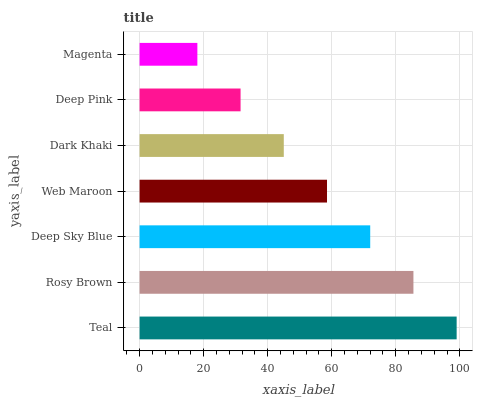Is Magenta the minimum?
Answer yes or no. Yes. Is Teal the maximum?
Answer yes or no. Yes. Is Rosy Brown the minimum?
Answer yes or no. No. Is Rosy Brown the maximum?
Answer yes or no. No. Is Teal greater than Rosy Brown?
Answer yes or no. Yes. Is Rosy Brown less than Teal?
Answer yes or no. Yes. Is Rosy Brown greater than Teal?
Answer yes or no. No. Is Teal less than Rosy Brown?
Answer yes or no. No. Is Web Maroon the high median?
Answer yes or no. Yes. Is Web Maroon the low median?
Answer yes or no. Yes. Is Deep Pink the high median?
Answer yes or no. No. Is Deep Sky Blue the low median?
Answer yes or no. No. 